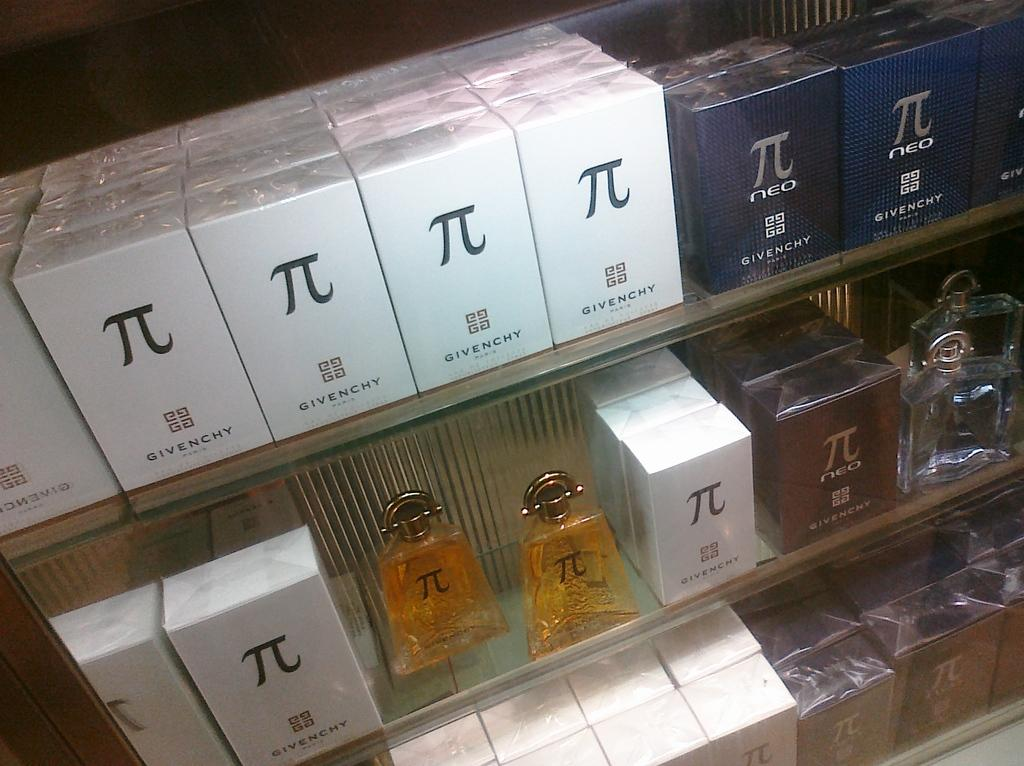Provide a one-sentence caption for the provided image. a box with the name Givenchy written on it. 